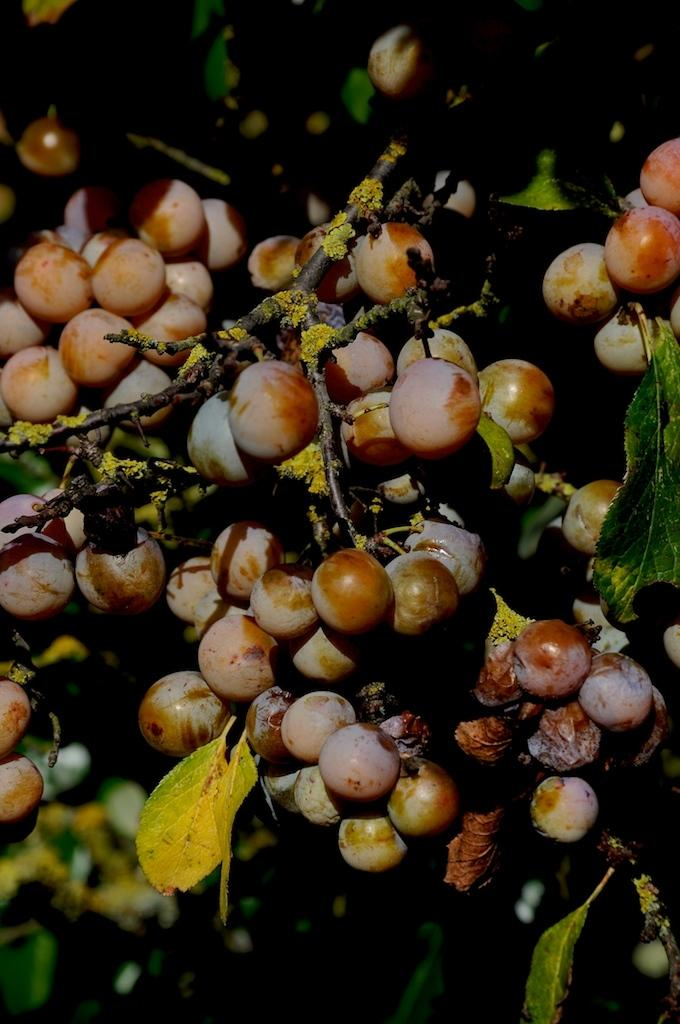What type of food items are present in the image? There are fruits in the image. What else can be seen in the image besides the fruits? There are leaves in the image. How are the leaves connected to the rest of the plant? The leaves are attached to stems in the image. How many tickets are visible in the image? There are no tickets present in the image. What type of coil can be seen wrapped around the fruits in the image? There is no coil present in the image; the fruits and leaves are not wrapped in any coil. 